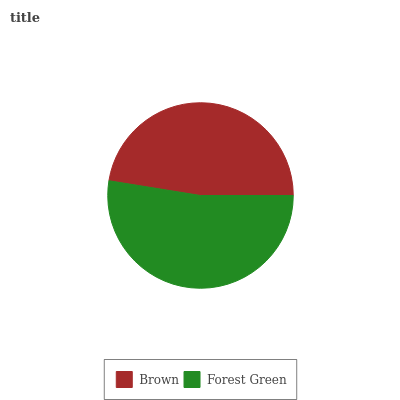Is Brown the minimum?
Answer yes or no. Yes. Is Forest Green the maximum?
Answer yes or no. Yes. Is Forest Green the minimum?
Answer yes or no. No. Is Forest Green greater than Brown?
Answer yes or no. Yes. Is Brown less than Forest Green?
Answer yes or no. Yes. Is Brown greater than Forest Green?
Answer yes or no. No. Is Forest Green less than Brown?
Answer yes or no. No. Is Forest Green the high median?
Answer yes or no. Yes. Is Brown the low median?
Answer yes or no. Yes. Is Brown the high median?
Answer yes or no. No. Is Forest Green the low median?
Answer yes or no. No. 